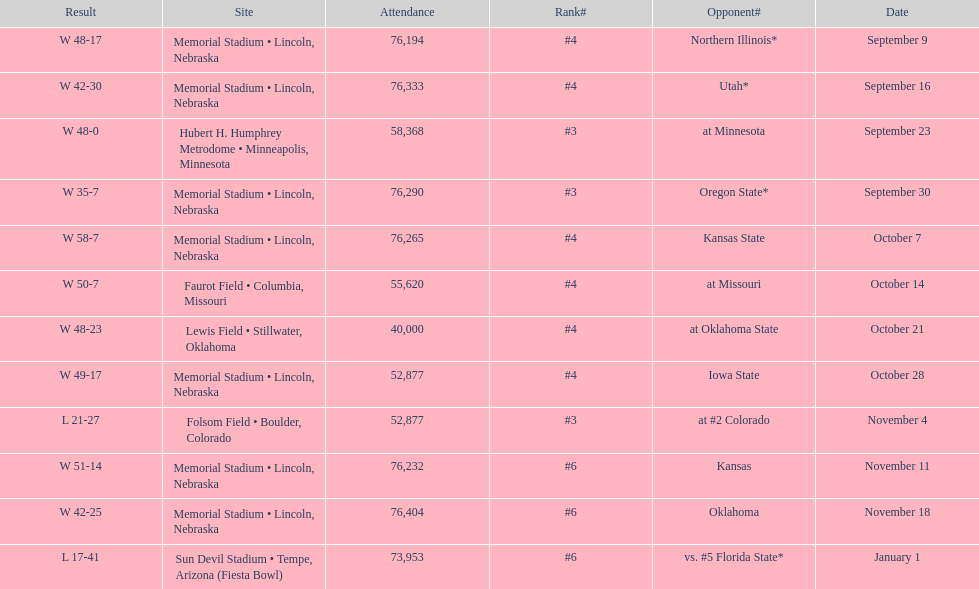On average how many times was w listed as the result? 10. 